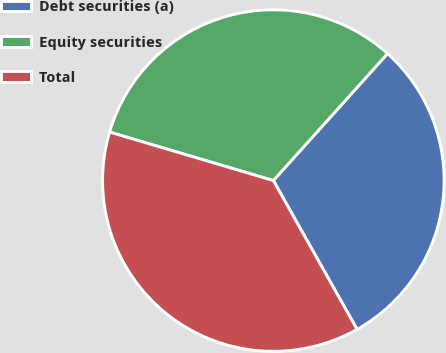<chart> <loc_0><loc_0><loc_500><loc_500><pie_chart><fcel>Debt securities (a)<fcel>Equity securities<fcel>Total<nl><fcel>30.19%<fcel>32.08%<fcel>37.74%<nl></chart> 